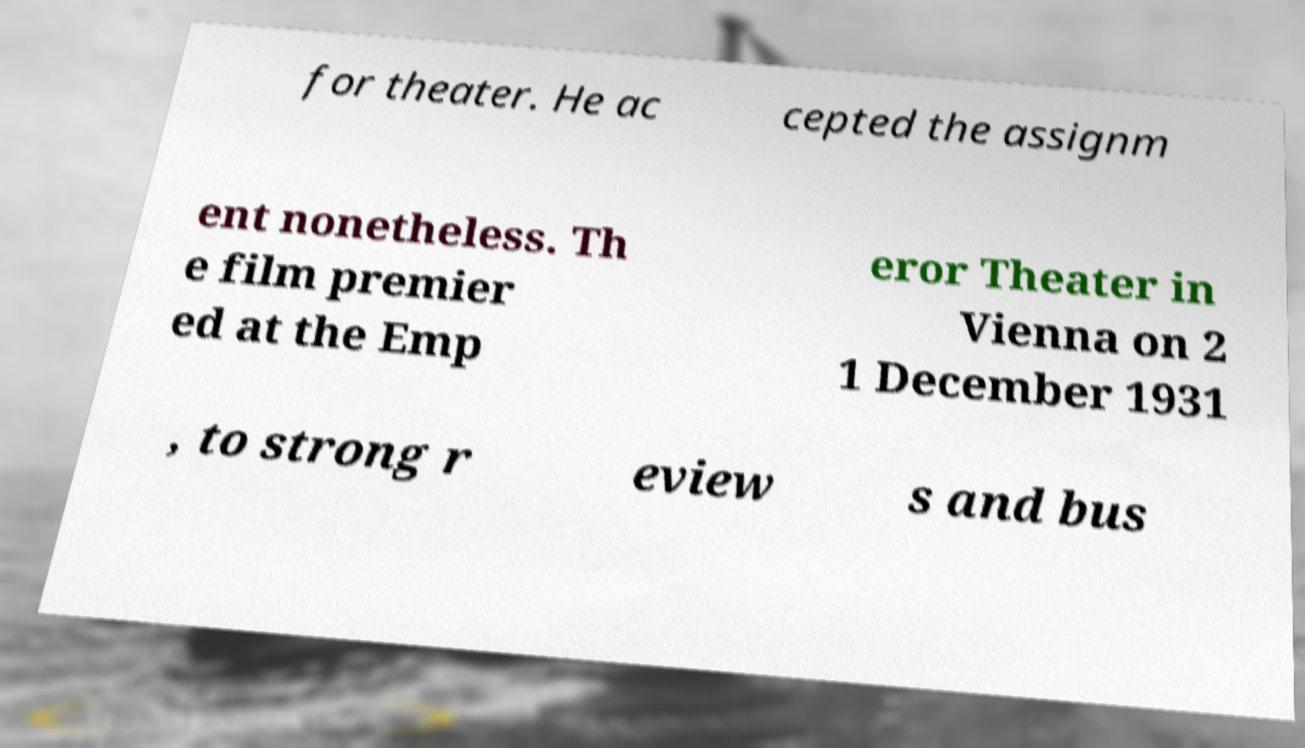Could you assist in decoding the text presented in this image and type it out clearly? for theater. He ac cepted the assignm ent nonetheless. Th e film premier ed at the Emp eror Theater in Vienna on 2 1 December 1931 , to strong r eview s and bus 